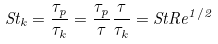Convert formula to latex. <formula><loc_0><loc_0><loc_500><loc_500>S t _ { k } = \frac { \tau _ { p } } { \tau _ { k } } = \frac { \tau _ { p } } { \tau } \frac { \tau } { \tau _ { k } } = S t R e ^ { 1 / 2 }</formula> 